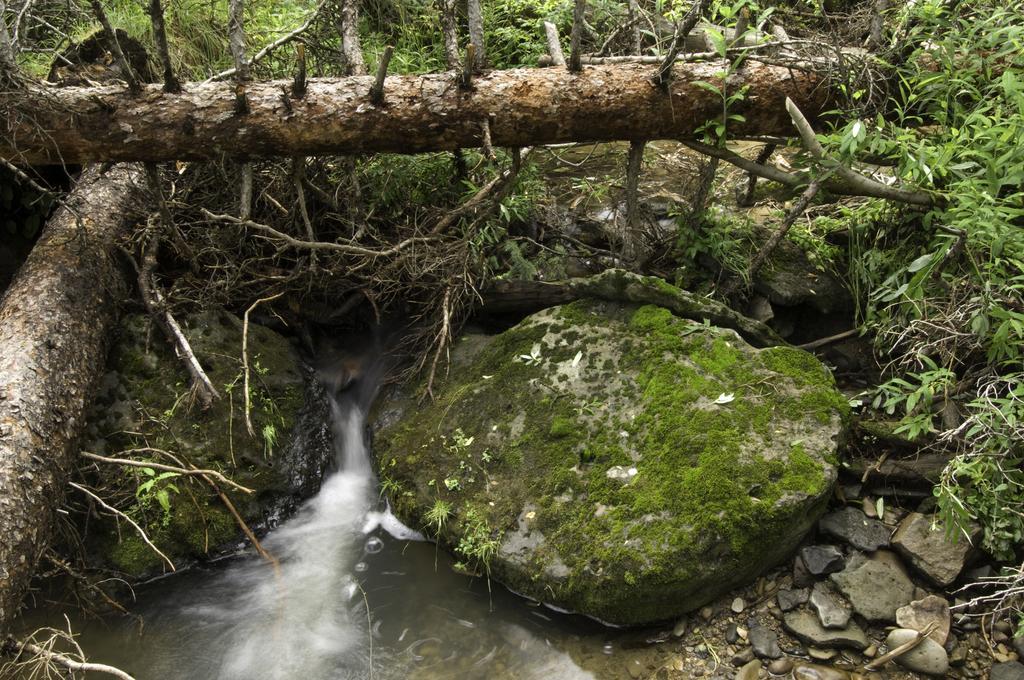Could you give a brief overview of what you see in this image? At the bottom of the image we can see there is water flowing between the rocks, above it there are trunks, plants and rocks. 